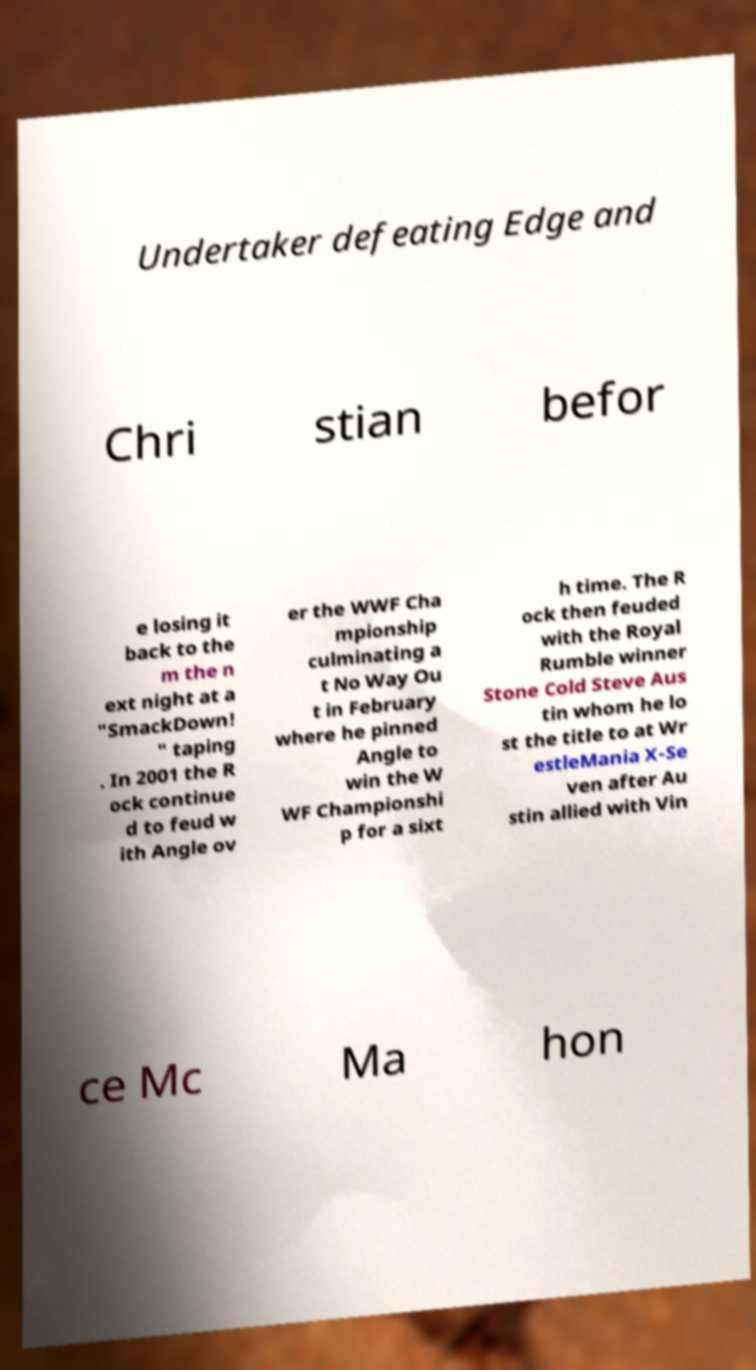Please read and relay the text visible in this image. What does it say? Undertaker defeating Edge and Chri stian befor e losing it back to the m the n ext night at a "SmackDown! " taping . In 2001 the R ock continue d to feud w ith Angle ov er the WWF Cha mpionship culminating a t No Way Ou t in February where he pinned Angle to win the W WF Championshi p for a sixt h time. The R ock then feuded with the Royal Rumble winner Stone Cold Steve Aus tin whom he lo st the title to at Wr estleMania X-Se ven after Au stin allied with Vin ce Mc Ma hon 